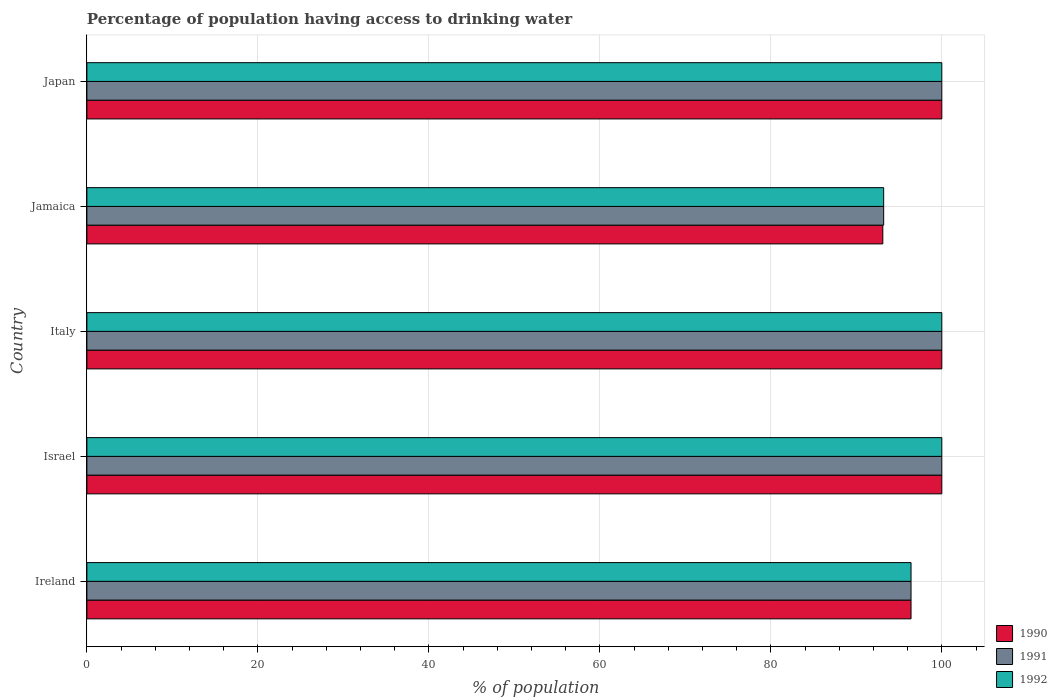How many different coloured bars are there?
Offer a very short reply. 3. How many groups of bars are there?
Make the answer very short. 5. How many bars are there on the 5th tick from the bottom?
Give a very brief answer. 3. Across all countries, what is the maximum percentage of population having access to drinking water in 1991?
Offer a very short reply. 100. Across all countries, what is the minimum percentage of population having access to drinking water in 1991?
Your answer should be compact. 93.2. In which country was the percentage of population having access to drinking water in 1991 minimum?
Your response must be concise. Jamaica. What is the total percentage of population having access to drinking water in 1991 in the graph?
Ensure brevity in your answer.  489.6. What is the difference between the percentage of population having access to drinking water in 1991 in Ireland and that in Israel?
Provide a succinct answer. -3.6. What is the difference between the percentage of population having access to drinking water in 1990 in Israel and the percentage of population having access to drinking water in 1992 in Italy?
Ensure brevity in your answer.  0. What is the average percentage of population having access to drinking water in 1992 per country?
Ensure brevity in your answer.  97.92. What is the difference between the percentage of population having access to drinking water in 1991 and percentage of population having access to drinking water in 1992 in Italy?
Ensure brevity in your answer.  0. What is the ratio of the percentage of population having access to drinking water in 1990 in Ireland to that in Israel?
Ensure brevity in your answer.  0.96. What is the difference between the highest and the lowest percentage of population having access to drinking water in 1991?
Offer a very short reply. 6.8. Is the sum of the percentage of population having access to drinking water in 1991 in Israel and Italy greater than the maximum percentage of population having access to drinking water in 1992 across all countries?
Offer a terse response. Yes. What does the 3rd bar from the top in Japan represents?
Offer a very short reply. 1990. What does the 1st bar from the bottom in Jamaica represents?
Ensure brevity in your answer.  1990. Is it the case that in every country, the sum of the percentage of population having access to drinking water in 1991 and percentage of population having access to drinking water in 1992 is greater than the percentage of population having access to drinking water in 1990?
Make the answer very short. Yes. How many bars are there?
Give a very brief answer. 15. Does the graph contain grids?
Ensure brevity in your answer.  Yes. Where does the legend appear in the graph?
Give a very brief answer. Bottom right. How many legend labels are there?
Provide a short and direct response. 3. How are the legend labels stacked?
Provide a short and direct response. Vertical. What is the title of the graph?
Make the answer very short. Percentage of population having access to drinking water. What is the label or title of the X-axis?
Keep it short and to the point. % of population. What is the % of population in 1990 in Ireland?
Offer a very short reply. 96.4. What is the % of population of 1991 in Ireland?
Keep it short and to the point. 96.4. What is the % of population in 1992 in Ireland?
Ensure brevity in your answer.  96.4. What is the % of population in 1991 in Israel?
Your answer should be compact. 100. What is the % of population in 1991 in Italy?
Provide a short and direct response. 100. What is the % of population in 1990 in Jamaica?
Ensure brevity in your answer.  93.1. What is the % of population in 1991 in Jamaica?
Provide a short and direct response. 93.2. What is the % of population in 1992 in Jamaica?
Make the answer very short. 93.2. What is the % of population of 1990 in Japan?
Offer a terse response. 100. What is the % of population of 1992 in Japan?
Provide a succinct answer. 100. Across all countries, what is the minimum % of population of 1990?
Make the answer very short. 93.1. Across all countries, what is the minimum % of population in 1991?
Give a very brief answer. 93.2. Across all countries, what is the minimum % of population of 1992?
Keep it short and to the point. 93.2. What is the total % of population in 1990 in the graph?
Your answer should be compact. 489.5. What is the total % of population of 1991 in the graph?
Your response must be concise. 489.6. What is the total % of population in 1992 in the graph?
Offer a terse response. 489.6. What is the difference between the % of population of 1990 in Ireland and that in Italy?
Provide a short and direct response. -3.6. What is the difference between the % of population in 1991 in Ireland and that in Italy?
Ensure brevity in your answer.  -3.6. What is the difference between the % of population in 1992 in Ireland and that in Italy?
Give a very brief answer. -3.6. What is the difference between the % of population of 1991 in Ireland and that in Jamaica?
Provide a succinct answer. 3.2. What is the difference between the % of population in 1991 in Ireland and that in Japan?
Keep it short and to the point. -3.6. What is the difference between the % of population in 1990 in Israel and that in Jamaica?
Ensure brevity in your answer.  6.9. What is the difference between the % of population in 1991 in Israel and that in Jamaica?
Ensure brevity in your answer.  6.8. What is the difference between the % of population of 1990 in Israel and that in Japan?
Your answer should be compact. 0. What is the difference between the % of population of 1991 in Israel and that in Japan?
Give a very brief answer. 0. What is the difference between the % of population of 1992 in Israel and that in Japan?
Provide a short and direct response. 0. What is the difference between the % of population in 1991 in Italy and that in Jamaica?
Your response must be concise. 6.8. What is the difference between the % of population of 1992 in Italy and that in Jamaica?
Provide a short and direct response. 6.8. What is the difference between the % of population of 1991 in Italy and that in Japan?
Offer a terse response. 0. What is the difference between the % of population in 1992 in Italy and that in Japan?
Provide a short and direct response. 0. What is the difference between the % of population of 1990 in Jamaica and that in Japan?
Offer a terse response. -6.9. What is the difference between the % of population in 1991 in Jamaica and that in Japan?
Offer a very short reply. -6.8. What is the difference between the % of population of 1992 in Jamaica and that in Japan?
Your answer should be compact. -6.8. What is the difference between the % of population of 1990 in Ireland and the % of population of 1992 in Israel?
Provide a succinct answer. -3.6. What is the difference between the % of population of 1991 in Ireland and the % of population of 1992 in Israel?
Offer a terse response. -3.6. What is the difference between the % of population of 1990 in Ireland and the % of population of 1991 in Italy?
Offer a very short reply. -3.6. What is the difference between the % of population in 1990 in Ireland and the % of population in 1992 in Italy?
Provide a succinct answer. -3.6. What is the difference between the % of population of 1991 in Ireland and the % of population of 1992 in Italy?
Provide a succinct answer. -3.6. What is the difference between the % of population in 1991 in Ireland and the % of population in 1992 in Jamaica?
Make the answer very short. 3.2. What is the difference between the % of population of 1990 in Israel and the % of population of 1991 in Italy?
Keep it short and to the point. 0. What is the difference between the % of population in 1990 in Israel and the % of population in 1992 in Italy?
Provide a succinct answer. 0. What is the difference between the % of population in 1990 in Israel and the % of population in 1992 in Jamaica?
Provide a succinct answer. 6.8. What is the difference between the % of population of 1990 in Israel and the % of population of 1992 in Japan?
Offer a very short reply. 0. What is the difference between the % of population in 1990 in Italy and the % of population in 1992 in Jamaica?
Your answer should be compact. 6.8. What is the difference between the % of population in 1990 in Italy and the % of population in 1991 in Japan?
Your response must be concise. 0. What is the difference between the % of population of 1991 in Jamaica and the % of population of 1992 in Japan?
Your response must be concise. -6.8. What is the average % of population in 1990 per country?
Provide a short and direct response. 97.9. What is the average % of population of 1991 per country?
Provide a succinct answer. 97.92. What is the average % of population in 1992 per country?
Make the answer very short. 97.92. What is the difference between the % of population of 1990 and % of population of 1992 in Ireland?
Provide a short and direct response. 0. What is the difference between the % of population of 1991 and % of population of 1992 in Israel?
Your response must be concise. 0. What is the difference between the % of population in 1990 and % of population in 1991 in Italy?
Make the answer very short. 0. What is the difference between the % of population of 1990 and % of population of 1992 in Italy?
Make the answer very short. 0. What is the difference between the % of population in 1991 and % of population in 1992 in Italy?
Provide a short and direct response. 0. What is the difference between the % of population in 1990 and % of population in 1992 in Jamaica?
Offer a terse response. -0.1. What is the difference between the % of population in 1990 and % of population in 1991 in Japan?
Ensure brevity in your answer.  0. What is the difference between the % of population of 1990 and % of population of 1992 in Japan?
Keep it short and to the point. 0. What is the difference between the % of population of 1991 and % of population of 1992 in Japan?
Offer a very short reply. 0. What is the ratio of the % of population in 1991 in Ireland to that in Israel?
Offer a terse response. 0.96. What is the ratio of the % of population in 1991 in Ireland to that in Italy?
Keep it short and to the point. 0.96. What is the ratio of the % of population of 1990 in Ireland to that in Jamaica?
Your answer should be very brief. 1.04. What is the ratio of the % of population of 1991 in Ireland to that in Jamaica?
Make the answer very short. 1.03. What is the ratio of the % of population of 1992 in Ireland to that in Jamaica?
Your answer should be very brief. 1.03. What is the ratio of the % of population of 1991 in Ireland to that in Japan?
Offer a very short reply. 0.96. What is the ratio of the % of population in 1992 in Ireland to that in Japan?
Provide a short and direct response. 0.96. What is the ratio of the % of population in 1992 in Israel to that in Italy?
Your answer should be compact. 1. What is the ratio of the % of population in 1990 in Israel to that in Jamaica?
Offer a very short reply. 1.07. What is the ratio of the % of population in 1991 in Israel to that in Jamaica?
Offer a very short reply. 1.07. What is the ratio of the % of population in 1992 in Israel to that in Jamaica?
Your answer should be compact. 1.07. What is the ratio of the % of population in 1990 in Italy to that in Jamaica?
Provide a short and direct response. 1.07. What is the ratio of the % of population in 1991 in Italy to that in Jamaica?
Keep it short and to the point. 1.07. What is the ratio of the % of population of 1992 in Italy to that in Jamaica?
Your answer should be compact. 1.07. What is the ratio of the % of population in 1992 in Italy to that in Japan?
Your response must be concise. 1. What is the ratio of the % of population in 1990 in Jamaica to that in Japan?
Provide a short and direct response. 0.93. What is the ratio of the % of population in 1991 in Jamaica to that in Japan?
Provide a short and direct response. 0.93. What is the ratio of the % of population in 1992 in Jamaica to that in Japan?
Keep it short and to the point. 0.93. What is the difference between the highest and the second highest % of population of 1992?
Offer a terse response. 0. What is the difference between the highest and the lowest % of population in 1990?
Make the answer very short. 6.9. What is the difference between the highest and the lowest % of population in 1991?
Provide a short and direct response. 6.8. 